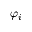Convert formula to latex. <formula><loc_0><loc_0><loc_500><loc_500>\varphi _ { i }</formula> 